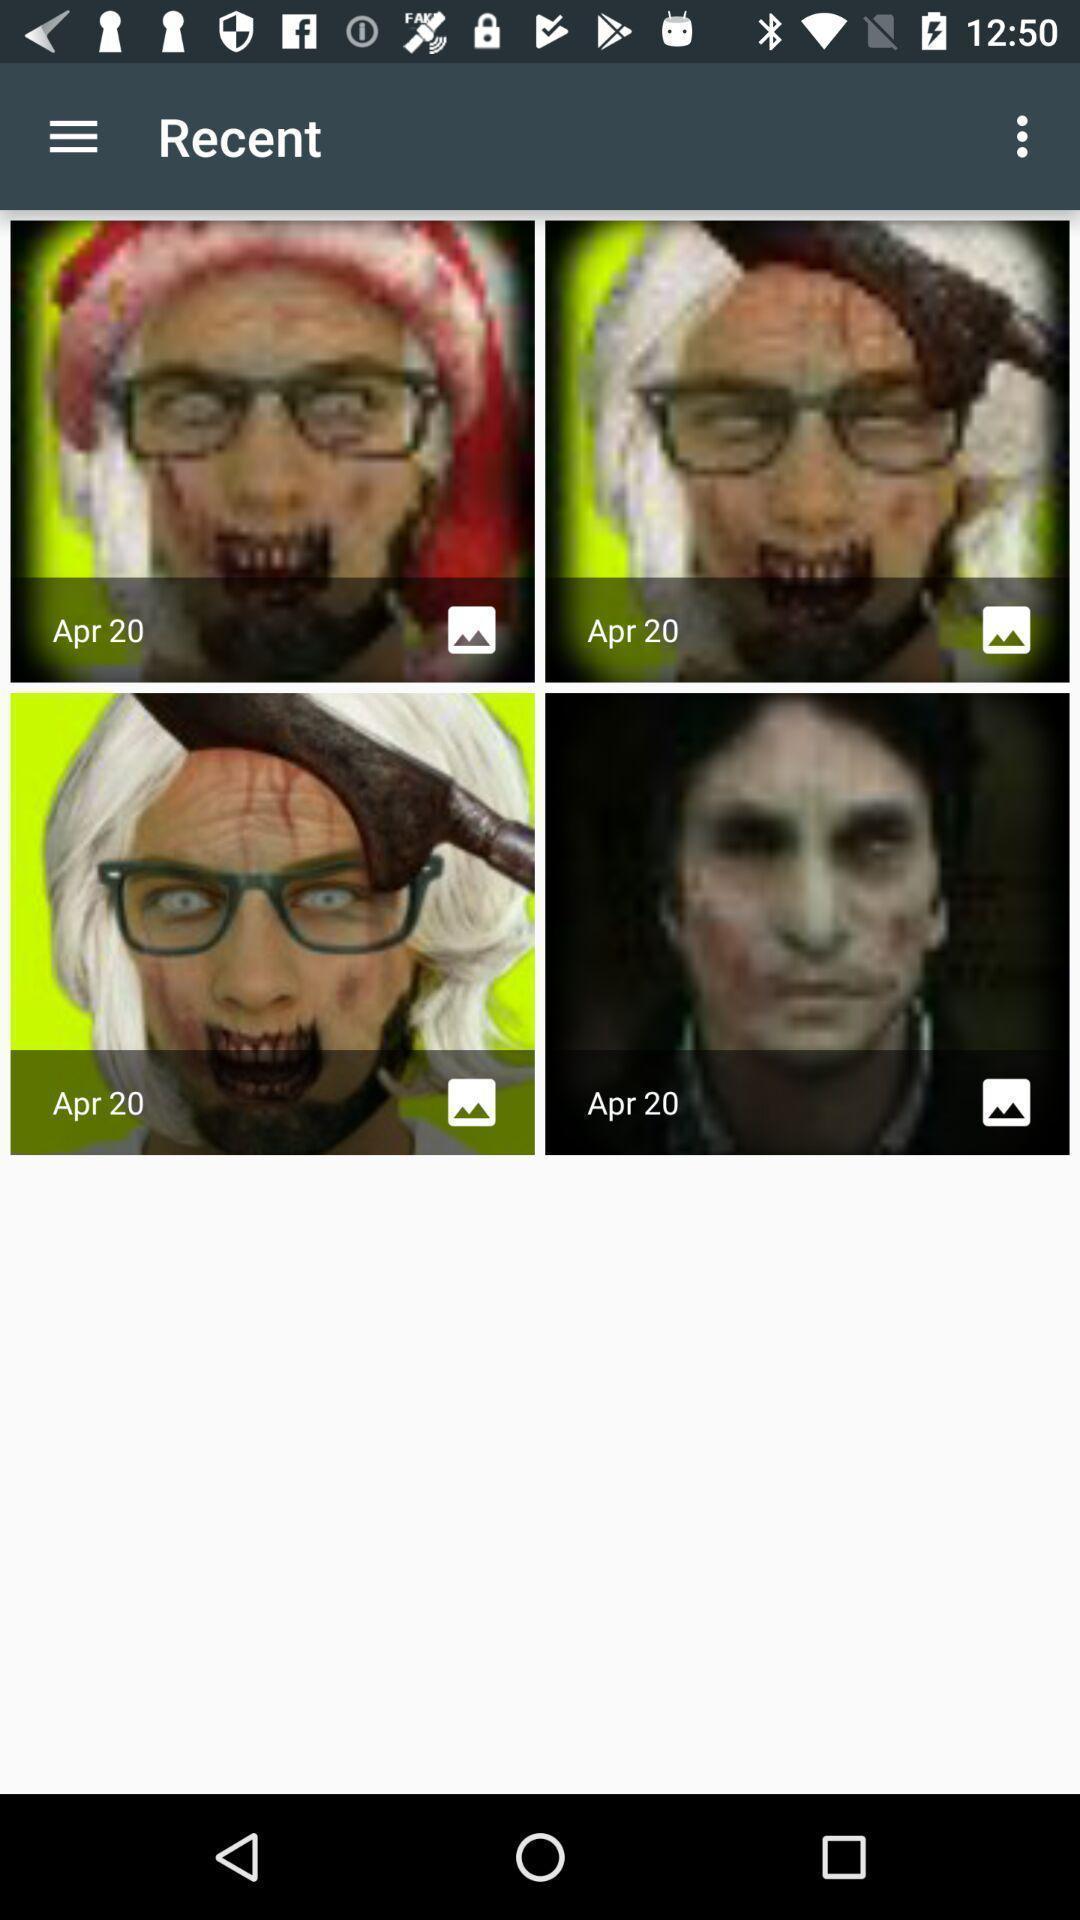Tell me about the visual elements in this screen capture. Screen displaying the images in recent folder. 